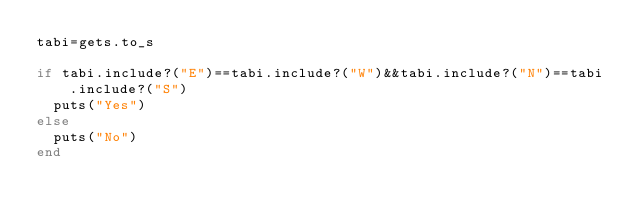Convert code to text. <code><loc_0><loc_0><loc_500><loc_500><_Ruby_>tabi=gets.to_s

if tabi.include?("E")==tabi.include?("W")&&tabi.include?("N")==tabi.include?("S")
	puts("Yes")
else
	puts("No")
end</code> 